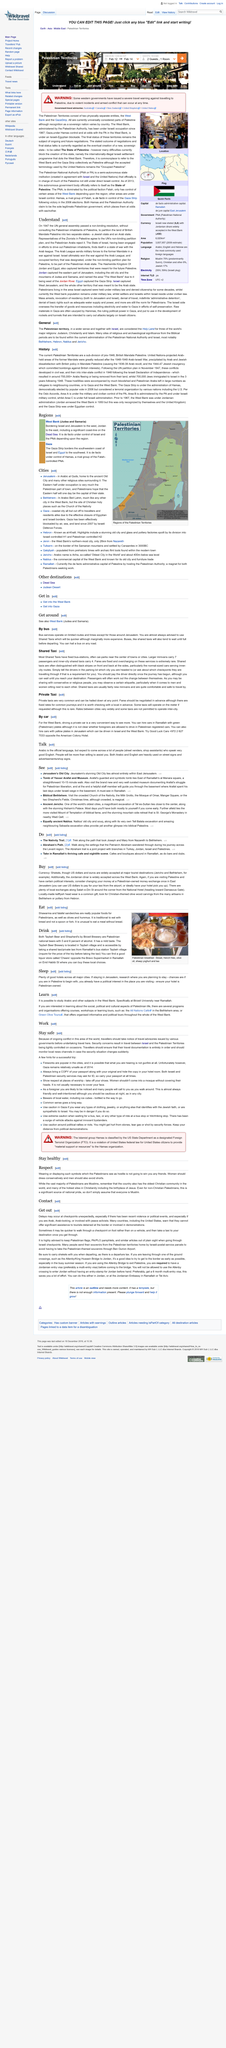Draw attention to some important aspects in this diagram. One can traverse the city of Jerusalem by utilizing either the bus or shared taxi system. It is advisable for women to dress modestly in Palestine. The article discusses sleeping and learning in Palestine. It is not appropriate for men to wear shorts in Palestine. In Ramallah, the license plates on cars for hire are green. 